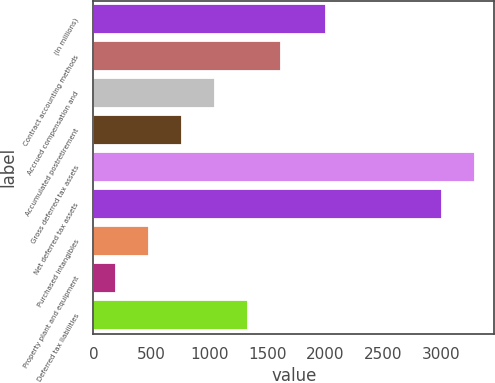<chart> <loc_0><loc_0><loc_500><loc_500><bar_chart><fcel>(In millions)<fcel>Contract accounting methods<fcel>Accrued compensation and<fcel>Accumulated postretirement<fcel>Gross deferred tax assets<fcel>Net deferred tax assets<fcel>Purchased intangibles<fcel>Property plant and equipment<fcel>Deferred tax liabilities<nl><fcel>2006<fcel>1621.5<fcel>1052.5<fcel>768<fcel>3294.5<fcel>3010<fcel>483.5<fcel>199<fcel>1337<nl></chart> 